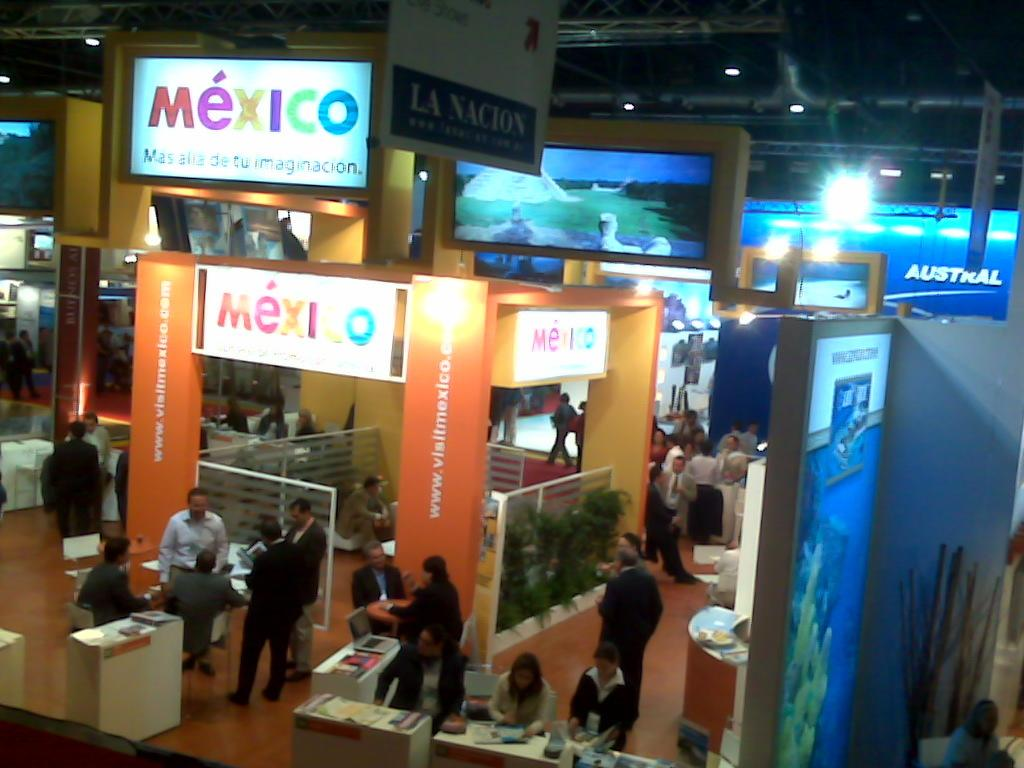<image>
Create a compact narrative representing the image presented. A store with the word Mexico hanging from the ceiling in different colored letters. 